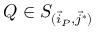<formula> <loc_0><loc_0><loc_500><loc_500>Q \in S _ { ( \vec { i } _ { P } , \vec { j } ^ { * } ) }</formula> 